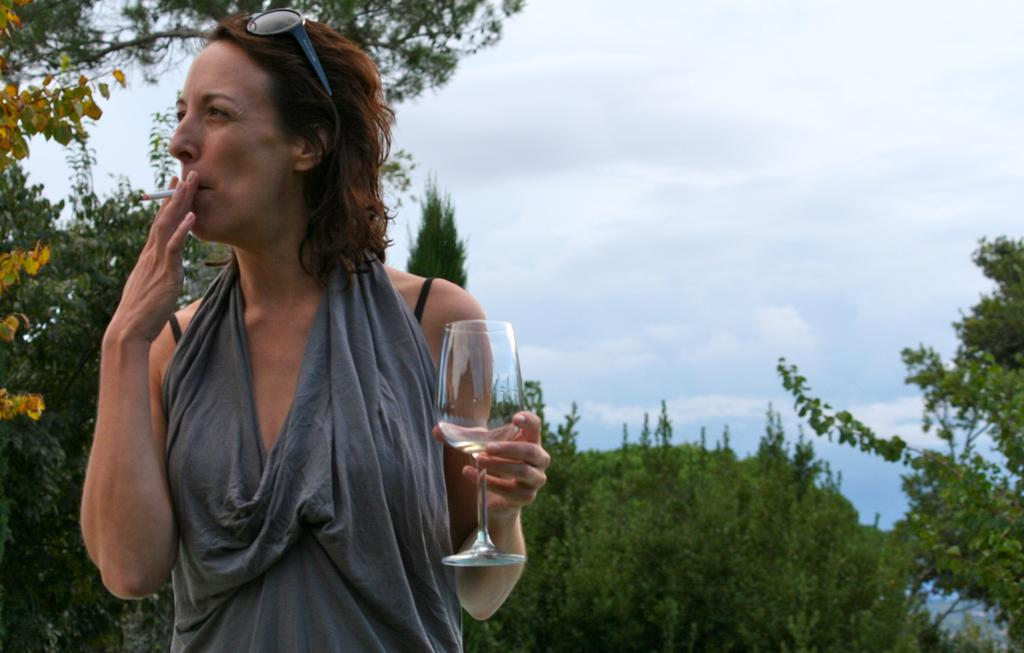Who is the main subject in the image? There is a woman in the image. What is the woman doing in the image? The woman is smoking a cigar and holding a glass in her hand. What is the woman wearing in the image? The woman is wearing goggles. What can be seen in the background of the image? There are trees and the sky visible in the background of the image. Where is the zipper located on the woman in the image? There is no zipper present on the woman in the image. What type of mailbox can be seen near the trees in the background? There is no mailbox visible in the image; only trees and the sky are present in the background. 